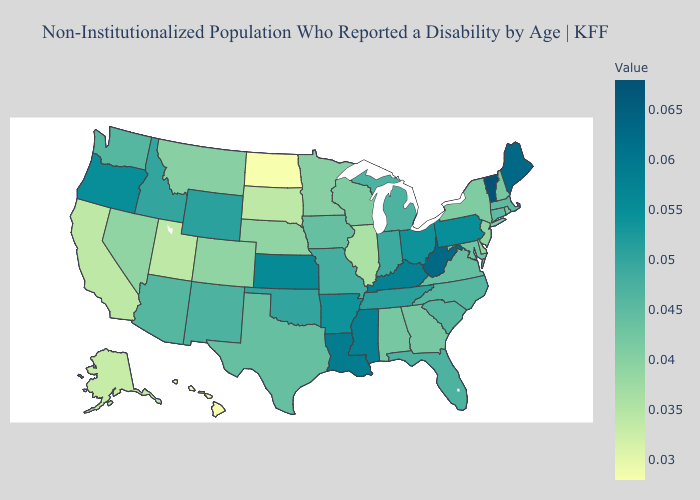Does Maryland have the highest value in the USA?
Be succinct. No. Does Utah have the lowest value in the USA?
Answer briefly. No. Which states have the highest value in the USA?
Short answer required. Vermont. Among the states that border New Mexico , which have the lowest value?
Quick response, please. Utah. Which states have the highest value in the USA?
Write a very short answer. Vermont. Among the states that border West Virginia , which have the lowest value?
Answer briefly. Maryland. 